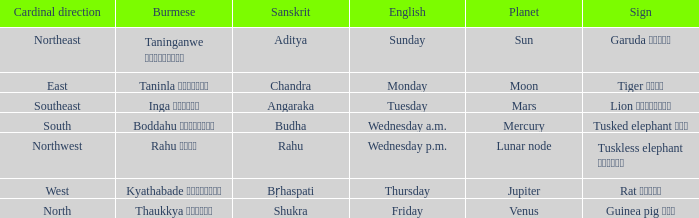Parse the full table. {'header': ['Cardinal direction', 'Burmese', 'Sanskrit', 'English', 'Planet', 'Sign'], 'rows': [['Northeast', 'Taninganwe တနင်္ဂနွေ', 'Aditya', 'Sunday', 'Sun', 'Garuda ဂဠုန်'], ['East', 'Taninla တနင်္လာ', 'Chandra', 'Monday', 'Moon', 'Tiger ကျား'], ['Southeast', 'Inga အင်္ဂါ', 'Angaraka', 'Tuesday', 'Mars', 'Lion ခြင်္သေ့'], ['South', 'Boddahu ဗုဒ္ဓဟူး', 'Budha', 'Wednesday a.m.', 'Mercury', 'Tusked elephant ဆင်'], ['Northwest', 'Rahu ရာဟု', 'Rahu', 'Wednesday p.m.', 'Lunar node', 'Tuskless elephant ဟိုင်း'], ['West', 'Kyathabade ကြာသပတေး', 'Bṛhaspati', 'Thursday', 'Jupiter', 'Rat ကြွက်'], ['North', 'Thaukkya သောကြာ', 'Shukra', 'Friday', 'Venus', 'Guinea pig ပူး']]} What is the Burmese term for Thursday? Kyathabade ကြာသပတေး. 